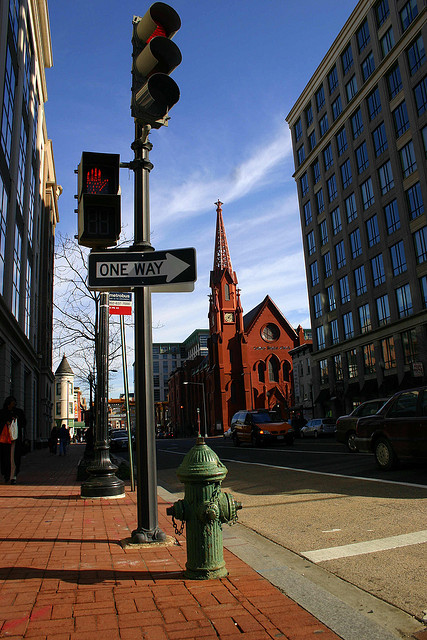What architectural style is the church in the background? The church in the background features characteristics of Gothic Revival architecture, including pointed arches and a steeply pitched roof. 